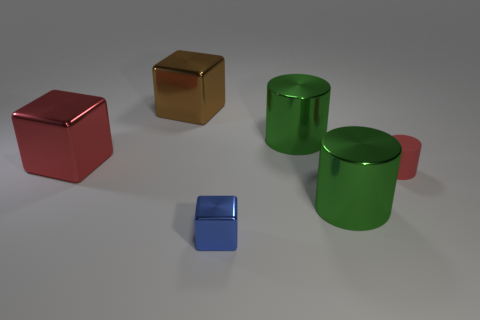How many big metallic objects are on the right side of the small metal thing?
Provide a short and direct response. 2. There is a tiny metallic thing that is the same shape as the large red shiny thing; what color is it?
Your answer should be compact. Blue. What material is the object that is to the right of the blue shiny object and in front of the red rubber object?
Give a very brief answer. Metal. Do the metallic cube that is on the right side of the brown metal block and the matte cylinder have the same size?
Your answer should be very brief. Yes. What is the material of the tiny blue thing?
Your answer should be very brief. Metal. There is a large thing that is in front of the matte object; what is its color?
Your answer should be very brief. Green. How many big objects are brown metallic objects or cubes?
Give a very brief answer. 2. There is a big block in front of the large brown cube; is it the same color as the large thing that is in front of the large red metallic block?
Offer a terse response. No. How many other things are the same color as the rubber object?
Give a very brief answer. 1. What number of blue objects are big matte things or shiny cubes?
Provide a succinct answer. 1. 